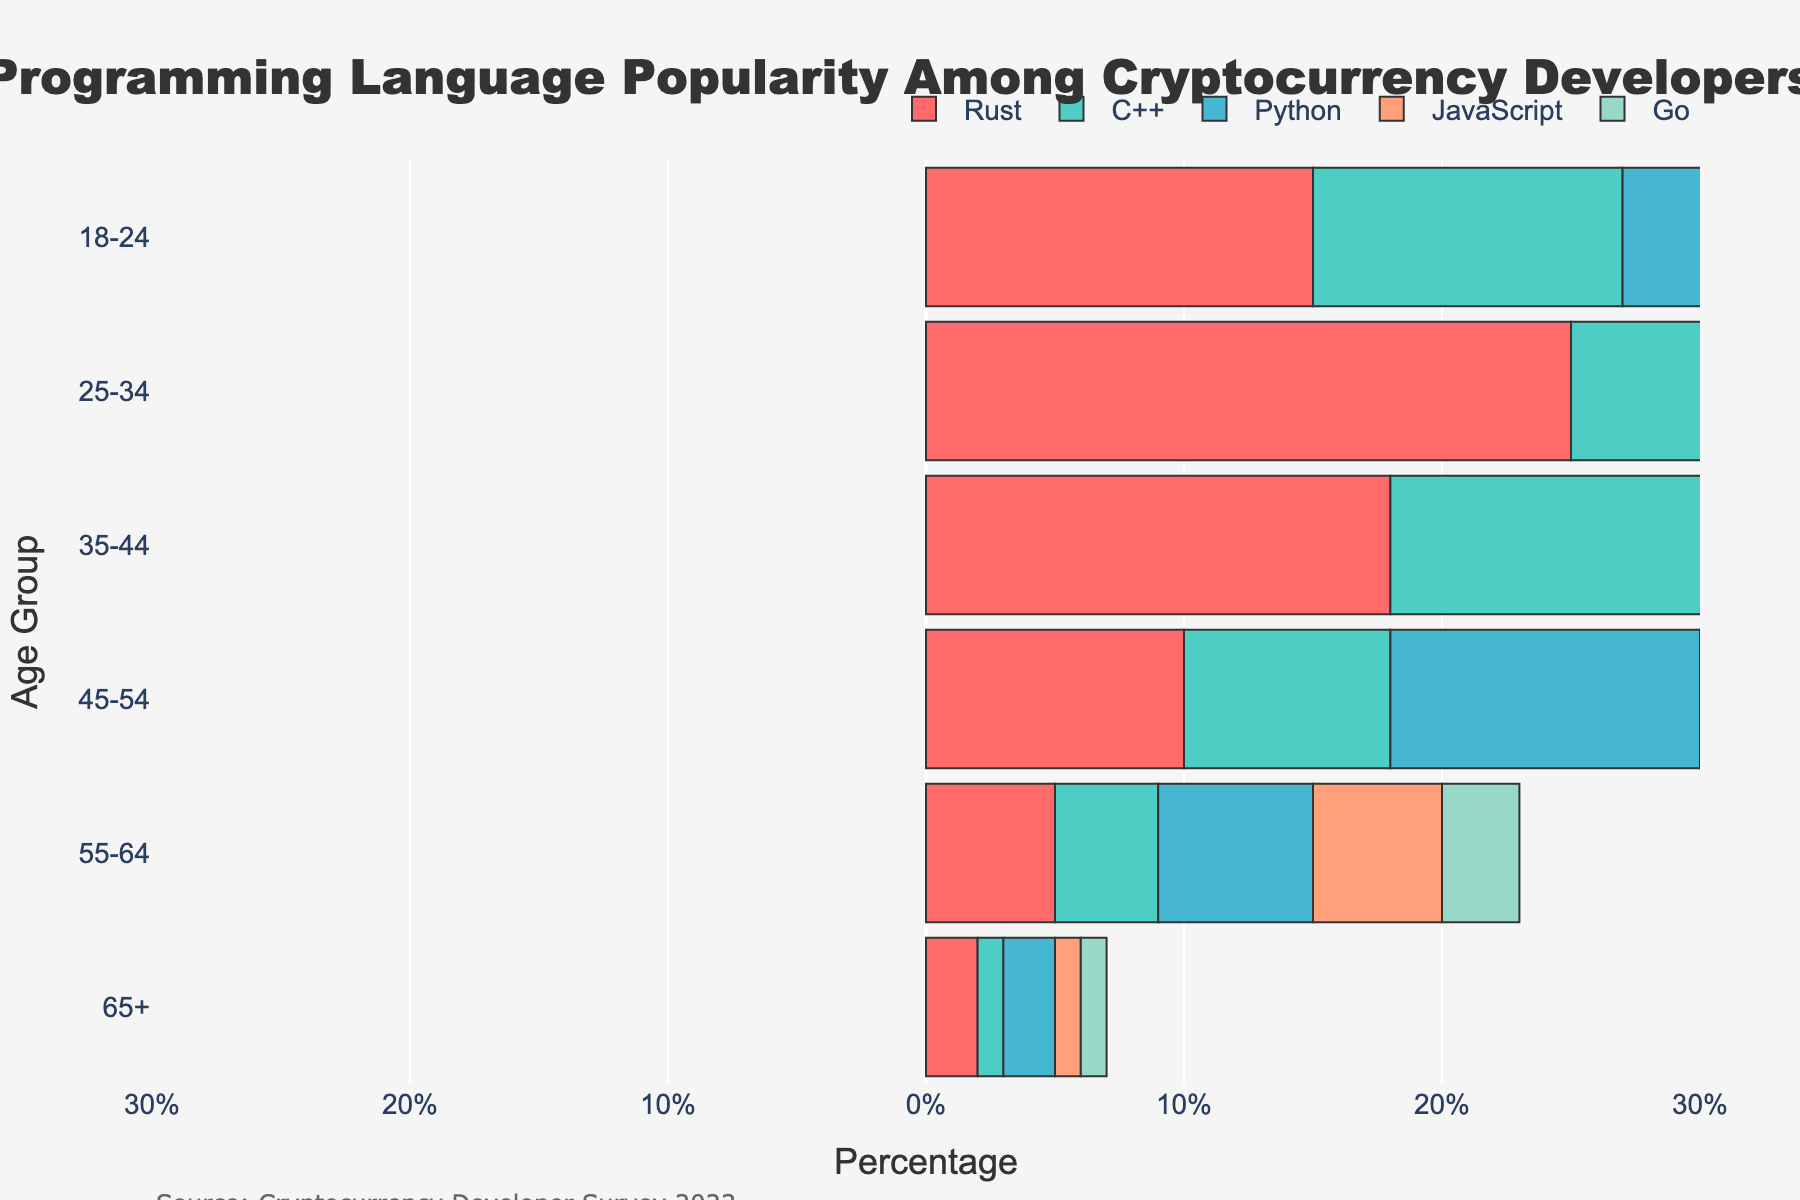What age group has the highest percentage of Python developers? Look at the bars for Python across all age groups. The highest percentage is in the 25-34 age group with 30%.
Answer: 25-34 How many more Rust developers are there in the 18-24 age group compared to the 55-64 age group? The percentage of Rust developers in the 18-24 age group is 15%, and in the 55-64 age group, it's 5%. The difference is 15% - 5% = 10%.
Answer: 10% Which programming language is least popular among developers aged 65+? Look at the bars for the 65+ age group across all programming languages. The lowest value is for C++ and JavaScript with 1% each.
Answer: C++ and JavaScript What is the total percentage of cryptocurrency developers aged 45-54 who use Python and Go combined? Sum the percentages of Python and Go in the 45-54 age group. Python is 12%, and Go is 7%. Total percentage is 12% + 7% = 19%.
Answer: 19% Is Python more popular than JavaScript among 35-44 age group developers? Compare the percentages for Python and JavaScript in the 35-44 age group. Python has 22%, and JavaScript has 16%, making Python more popular.
Answer: Yes What is the difference in percentage points between Rust developers and C++ developers in the 25-34 age group? Rust has 25% (considering the negative sign), and C++ has 20% in the 25-34 age group. The difference is 25% - 20% = 5%.
Answer: 5% How much more popular is Go than Rust in the 45-54 age group? Rust has 10% (considering the negative sign), and Go has 7% in the 45-54 age group. The difference is 10% - 7% = 3%.
Answer: 3% What age group shows the highest popularity for C++ developers? Look at the bars for C++ across all the age groups. The highest percentage is in the 25-34 age group with 20%.
Answer: 25-34 